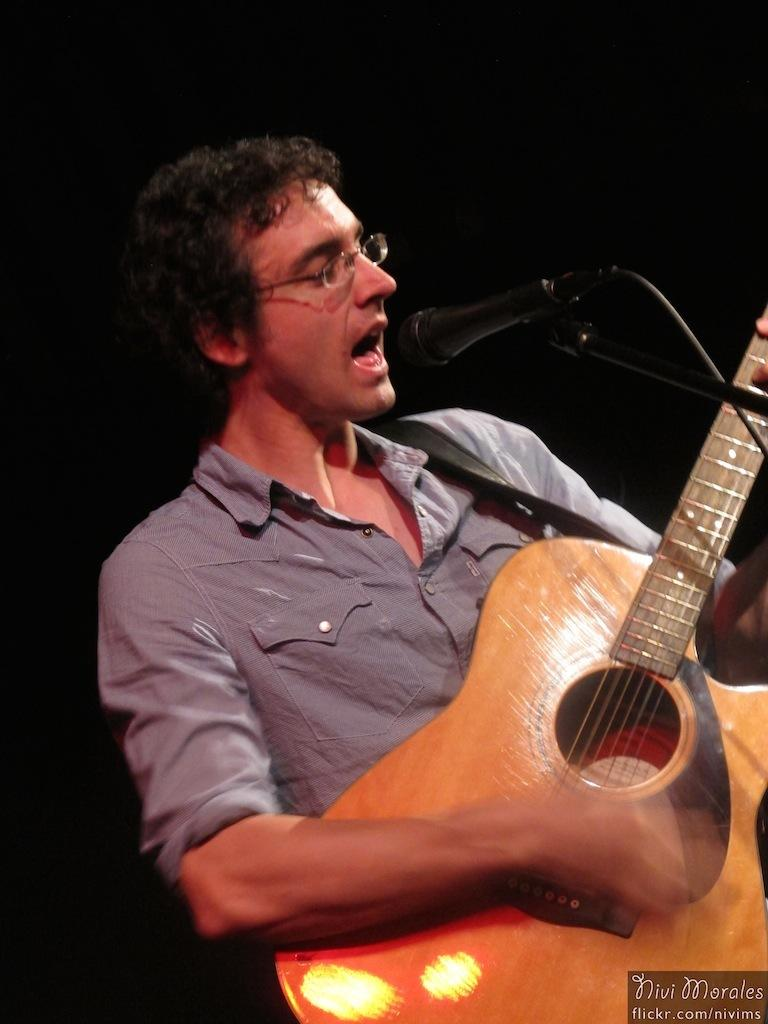What is the main subject of the picture? The main subject of the picture is a man. What is the man wearing in the picture? The man is wearing spectacles and a blue shirt. What is the man doing in the picture? The man is singing a song and playing the guitar. What object is in front of the man? There is a microphone in front of the man. What type of pleasure can be seen enjoying the song in the image? There is no indication of pleasure enjoying the song in the image, as it only shows a man singing and playing the guitar. Can you tell me how many hens are present in the image? There are no hens present in the image. 